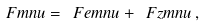<formula> <loc_0><loc_0><loc_500><loc_500>\ F m n u = \ F e m n u + \ F z m n u \, ,</formula> 